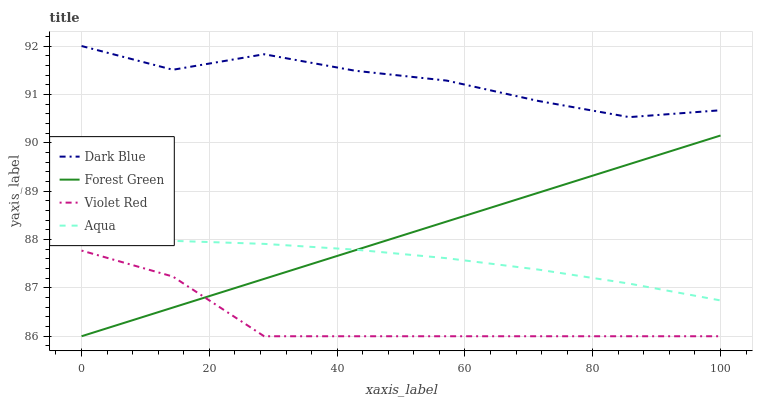Does Violet Red have the minimum area under the curve?
Answer yes or no. Yes. Does Dark Blue have the maximum area under the curve?
Answer yes or no. Yes. Does Forest Green have the minimum area under the curve?
Answer yes or no. No. Does Forest Green have the maximum area under the curve?
Answer yes or no. No. Is Forest Green the smoothest?
Answer yes or no. Yes. Is Dark Blue the roughest?
Answer yes or no. Yes. Is Aqua the smoothest?
Answer yes or no. No. Is Aqua the roughest?
Answer yes or no. No. Does Forest Green have the lowest value?
Answer yes or no. Yes. Does Aqua have the lowest value?
Answer yes or no. No. Does Dark Blue have the highest value?
Answer yes or no. Yes. Does Forest Green have the highest value?
Answer yes or no. No. Is Aqua less than Dark Blue?
Answer yes or no. Yes. Is Dark Blue greater than Forest Green?
Answer yes or no. Yes. Does Forest Green intersect Aqua?
Answer yes or no. Yes. Is Forest Green less than Aqua?
Answer yes or no. No. Is Forest Green greater than Aqua?
Answer yes or no. No. Does Aqua intersect Dark Blue?
Answer yes or no. No. 